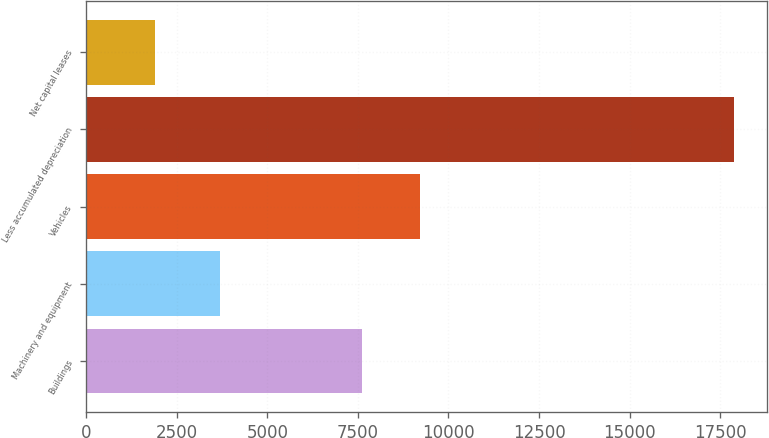<chart> <loc_0><loc_0><loc_500><loc_500><bar_chart><fcel>Buildings<fcel>Machinery and equipment<fcel>Vehicles<fcel>Less accumulated depreciation<fcel>Net capital leases<nl><fcel>7624<fcel>3700<fcel>9221.9<fcel>17883<fcel>1904<nl></chart> 